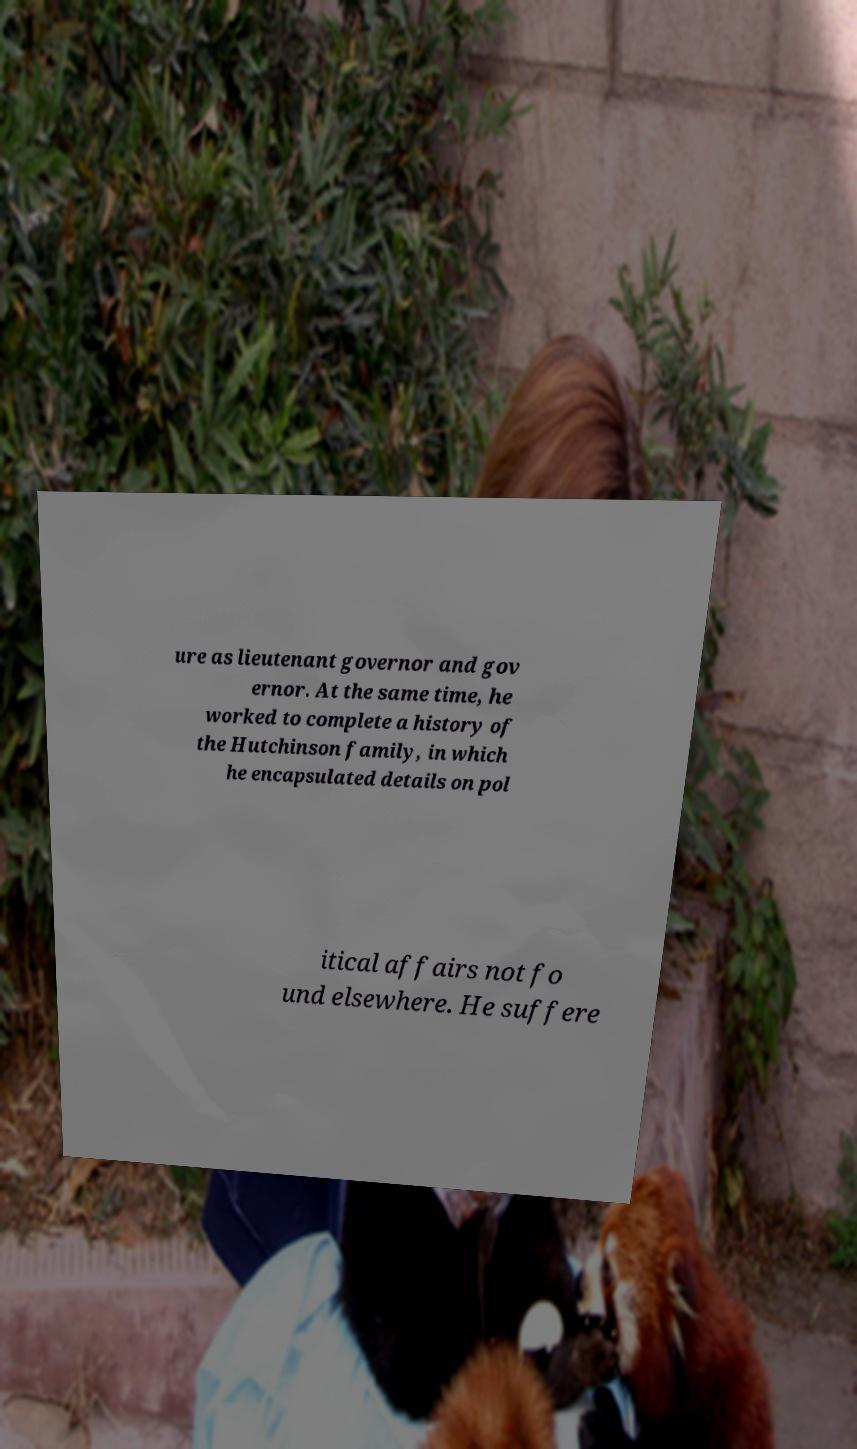Can you read and provide the text displayed in the image?This photo seems to have some interesting text. Can you extract and type it out for me? ure as lieutenant governor and gov ernor. At the same time, he worked to complete a history of the Hutchinson family, in which he encapsulated details on pol itical affairs not fo und elsewhere. He suffere 